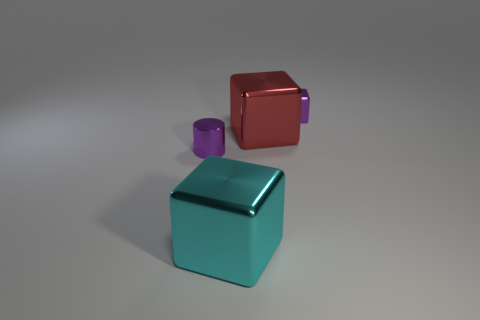Add 1 tiny cyan cubes. How many objects exist? 5 Subtract all cylinders. How many objects are left? 3 Add 1 large metallic cubes. How many large metallic cubes exist? 3 Subtract 0 green cubes. How many objects are left? 4 Subtract all big cyan things. Subtract all big rubber cylinders. How many objects are left? 3 Add 4 purple metallic things. How many purple metallic things are left? 6 